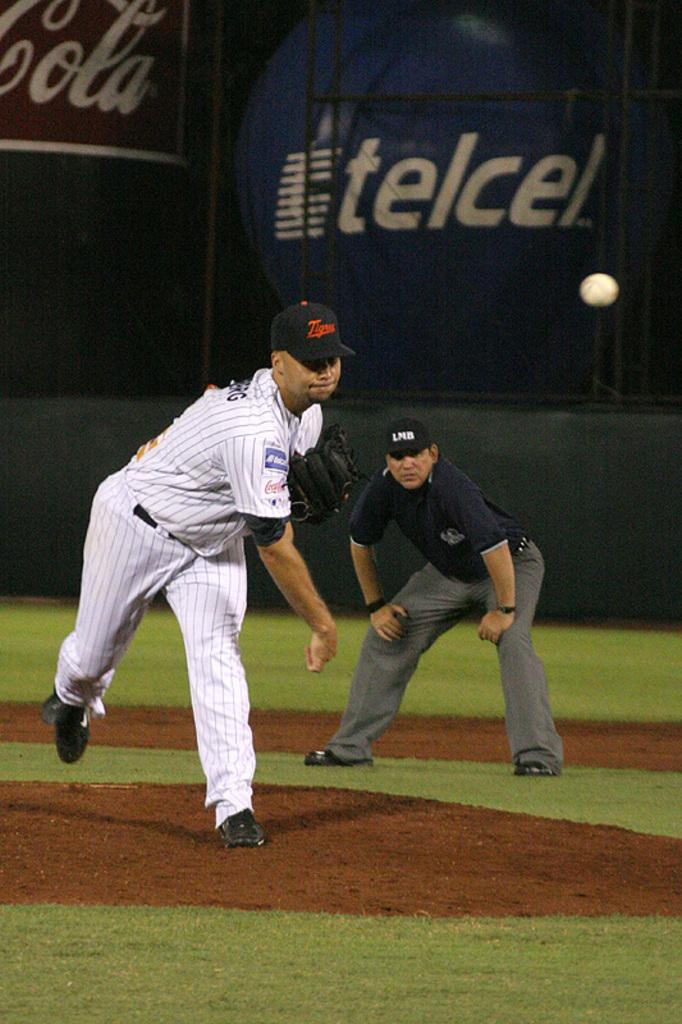<image>
Offer a succinct explanation of the picture presented. a player throwing a ball with telcel in the background 